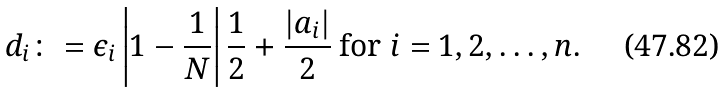<formula> <loc_0><loc_0><loc_500><loc_500>d _ { i } \colon = \epsilon _ { i } \left | 1 - \frac { 1 } { N } \right | \frac { 1 } { 2 } + \frac { | a _ { i } | } { 2 } \text { for } i = 1 , 2 , \dots , n .</formula> 